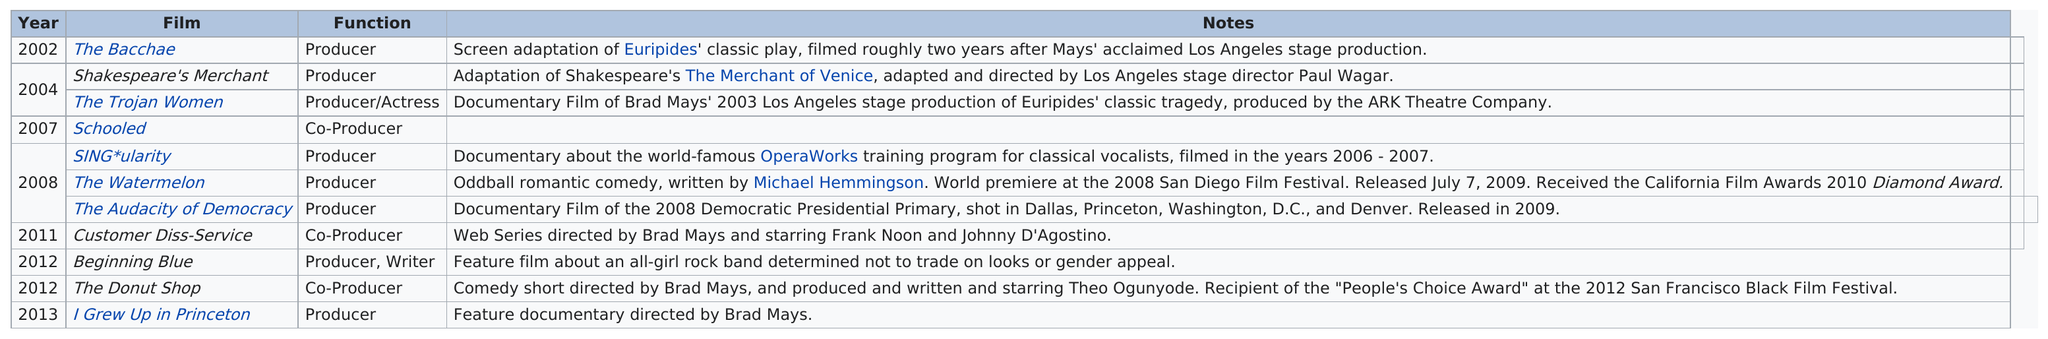Indicate a few pertinent items in this graphic. Lorenda Starfelt produced at least three films in the year 2008. Ms. Starfelt produced four films after 2010. The film was schooled out for a period of five years before beginning to shoot the blue scenes. The film that was released before the Audacity of Democracy was 'The Watermelon Thriller.' In 2008, there were at least three movies. 